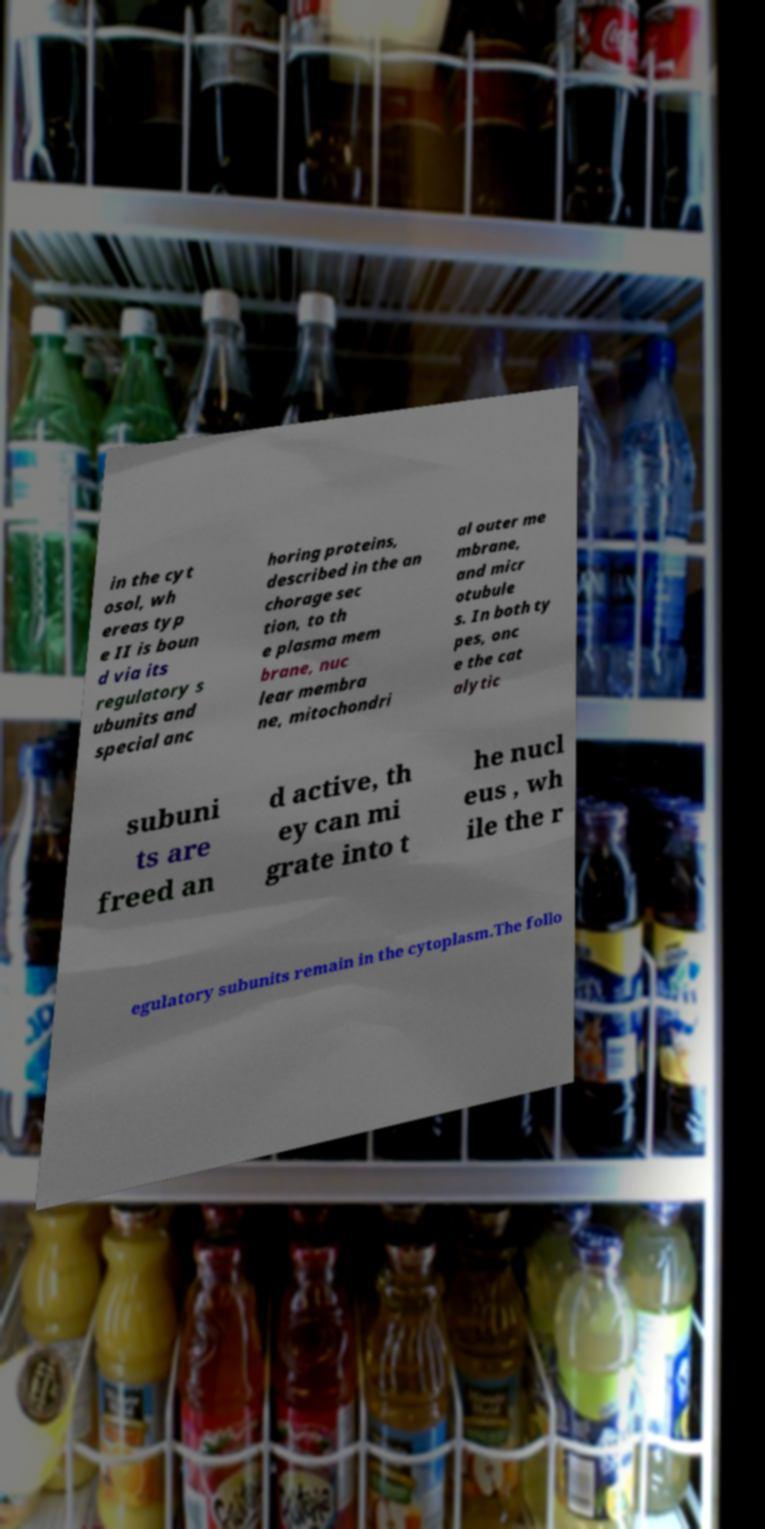Can you accurately transcribe the text from the provided image for me? in the cyt osol, wh ereas typ e II is boun d via its regulatory s ubunits and special anc horing proteins, described in the an chorage sec tion, to th e plasma mem brane, nuc lear membra ne, mitochondri al outer me mbrane, and micr otubule s. In both ty pes, onc e the cat alytic subuni ts are freed an d active, th ey can mi grate into t he nucl eus , wh ile the r egulatory subunits remain in the cytoplasm.The follo 